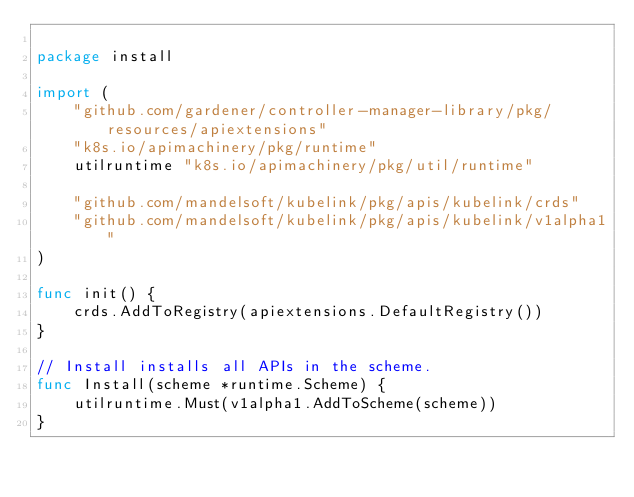Convert code to text. <code><loc_0><loc_0><loc_500><loc_500><_Go_>
package install

import (
	"github.com/gardener/controller-manager-library/pkg/resources/apiextensions"
	"k8s.io/apimachinery/pkg/runtime"
	utilruntime "k8s.io/apimachinery/pkg/util/runtime"

	"github.com/mandelsoft/kubelink/pkg/apis/kubelink/crds"
	"github.com/mandelsoft/kubelink/pkg/apis/kubelink/v1alpha1"
)

func init() {
	crds.AddToRegistry(apiextensions.DefaultRegistry())
}

// Install installs all APIs in the scheme.
func Install(scheme *runtime.Scheme) {
	utilruntime.Must(v1alpha1.AddToScheme(scheme))
}
</code> 